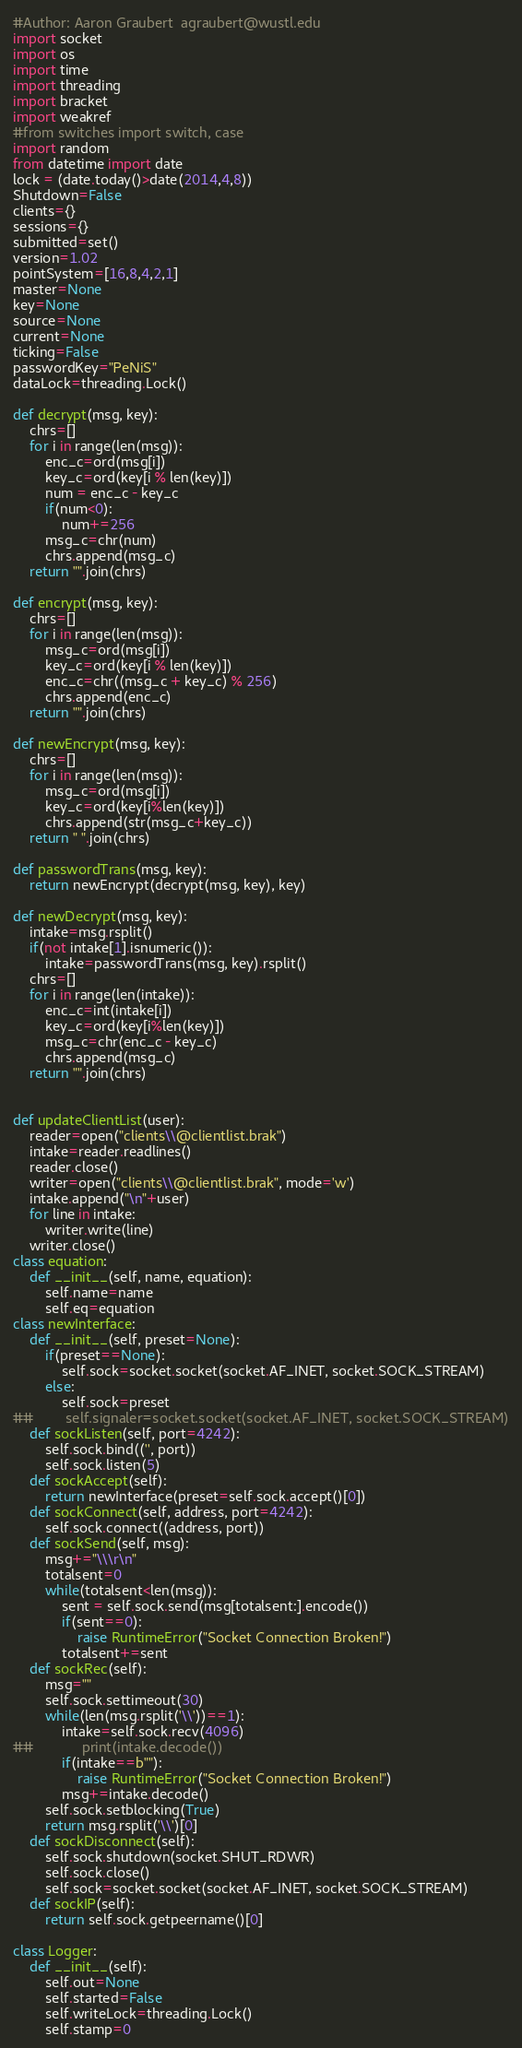<code> <loc_0><loc_0><loc_500><loc_500><_Python_>#Author: Aaron Graubert  agraubert@wustl.edu
import socket
import os
import time
import threading
import bracket
import weakref
#from switches import switch, case
import random
from datetime import date
lock = (date.today()>date(2014,4,8))
Shutdown=False
clients={}
sessions={}
submitted=set()
version=1.02
pointSystem=[16,8,4,2,1]
master=None
key=None
source=None
current=None
ticking=False
passwordKey="PeNiS"
dataLock=threading.Lock()

def decrypt(msg, key):
    chrs=[]
    for i in range(len(msg)):
        enc_c=ord(msg[i])
        key_c=ord(key[i % len(key)])
        num = enc_c - key_c
        if(num<0):
            num+=256
        msg_c=chr(num)
        chrs.append(msg_c)
    return "".join(chrs)

def encrypt(msg, key):
    chrs=[]
    for i in range(len(msg)):
        msg_c=ord(msg[i])
        key_c=ord(key[i % len(key)])
        enc_c=chr((msg_c + key_c) % 256)
        chrs.append(enc_c)
    return "".join(chrs)

def newEncrypt(msg, key):
    chrs=[]
    for i in range(len(msg)):
        msg_c=ord(msg[i])
        key_c=ord(key[i%len(key)])
        chrs.append(str(msg_c+key_c))
    return " ".join(chrs)

def passwordTrans(msg, key):
    return newEncrypt(decrypt(msg, key), key)

def newDecrypt(msg, key):
    intake=msg.rsplit()
    if(not intake[1].isnumeric()):
        intake=passwordTrans(msg, key).rsplit()
    chrs=[]
    for i in range(len(intake)):
        enc_c=int(intake[i])
        key_c=ord(key[i%len(key)])
        msg_c=chr(enc_c - key_c)
        chrs.append(msg_c)
    return "".join(chrs)


def updateClientList(user):
    reader=open("clients\\@clientlist.brak")
    intake=reader.readlines()
    reader.close()
    writer=open("clients\\@clientlist.brak", mode='w')
    intake.append("\n"+user)
    for line in intake:
        writer.write(line)
    writer.close()
class equation:
    def __init__(self, name, equation):
        self.name=name
        self.eq=equation
class newInterface:
    def __init__(self, preset=None):
        if(preset==None):
            self.sock=socket.socket(socket.AF_INET, socket.SOCK_STREAM)
        else:
            self.sock=preset
##        self.signaler=socket.socket(socket.AF_INET, socket.SOCK_STREAM)
    def sockListen(self, port=4242):
        self.sock.bind(('', port))
        self.sock.listen(5)
    def sockAccept(self):
        return newInterface(preset=self.sock.accept()[0])
    def sockConnect(self, address, port=4242):
        self.sock.connect((address, port))
    def sockSend(self, msg):        
        msg+="\\\r\n"
        totalsent=0
        while(totalsent<len(msg)):
            sent = self.sock.send(msg[totalsent:].encode())
            if(sent==0):
                raise RuntimeError("Socket Connection Broken!")
            totalsent+=sent
    def sockRec(self):
        msg=""
        self.sock.settimeout(30)
        while(len(msg.rsplit('\\'))==1):
            intake=self.sock.recv(4096)
##            print(intake.decode())
            if(intake==b""):
                raise RuntimeError("Socket Connection Broken!")
            msg+=intake.decode()
        self.sock.setblocking(True)
        return msg.rsplit('\\')[0]
    def sockDisconnect(self):
        self.sock.shutdown(socket.SHUT_RDWR)
        self.sock.close()
        self.sock=socket.socket(socket.AF_INET, socket.SOCK_STREAM)
    def sockIP(self):
        return self.sock.getpeername()[0]
    
class Logger:
    def __init__(self):
        self.out=None
        self.started=False
        self.writeLock=threading.Lock()
        self.stamp=0</code> 